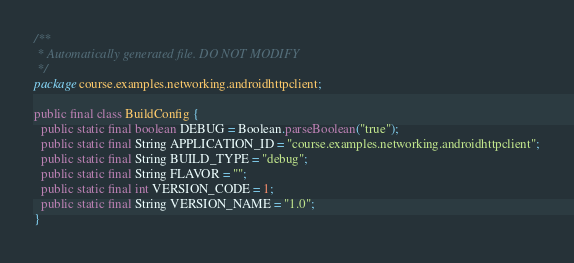Convert code to text. <code><loc_0><loc_0><loc_500><loc_500><_Java_>/**
 * Automatically generated file. DO NOT MODIFY
 */
package course.examples.networking.androidhttpclient;

public final class BuildConfig {
  public static final boolean DEBUG = Boolean.parseBoolean("true");
  public static final String APPLICATION_ID = "course.examples.networking.androidhttpclient";
  public static final String BUILD_TYPE = "debug";
  public static final String FLAVOR = "";
  public static final int VERSION_CODE = 1;
  public static final String VERSION_NAME = "1.0";
}
</code> 